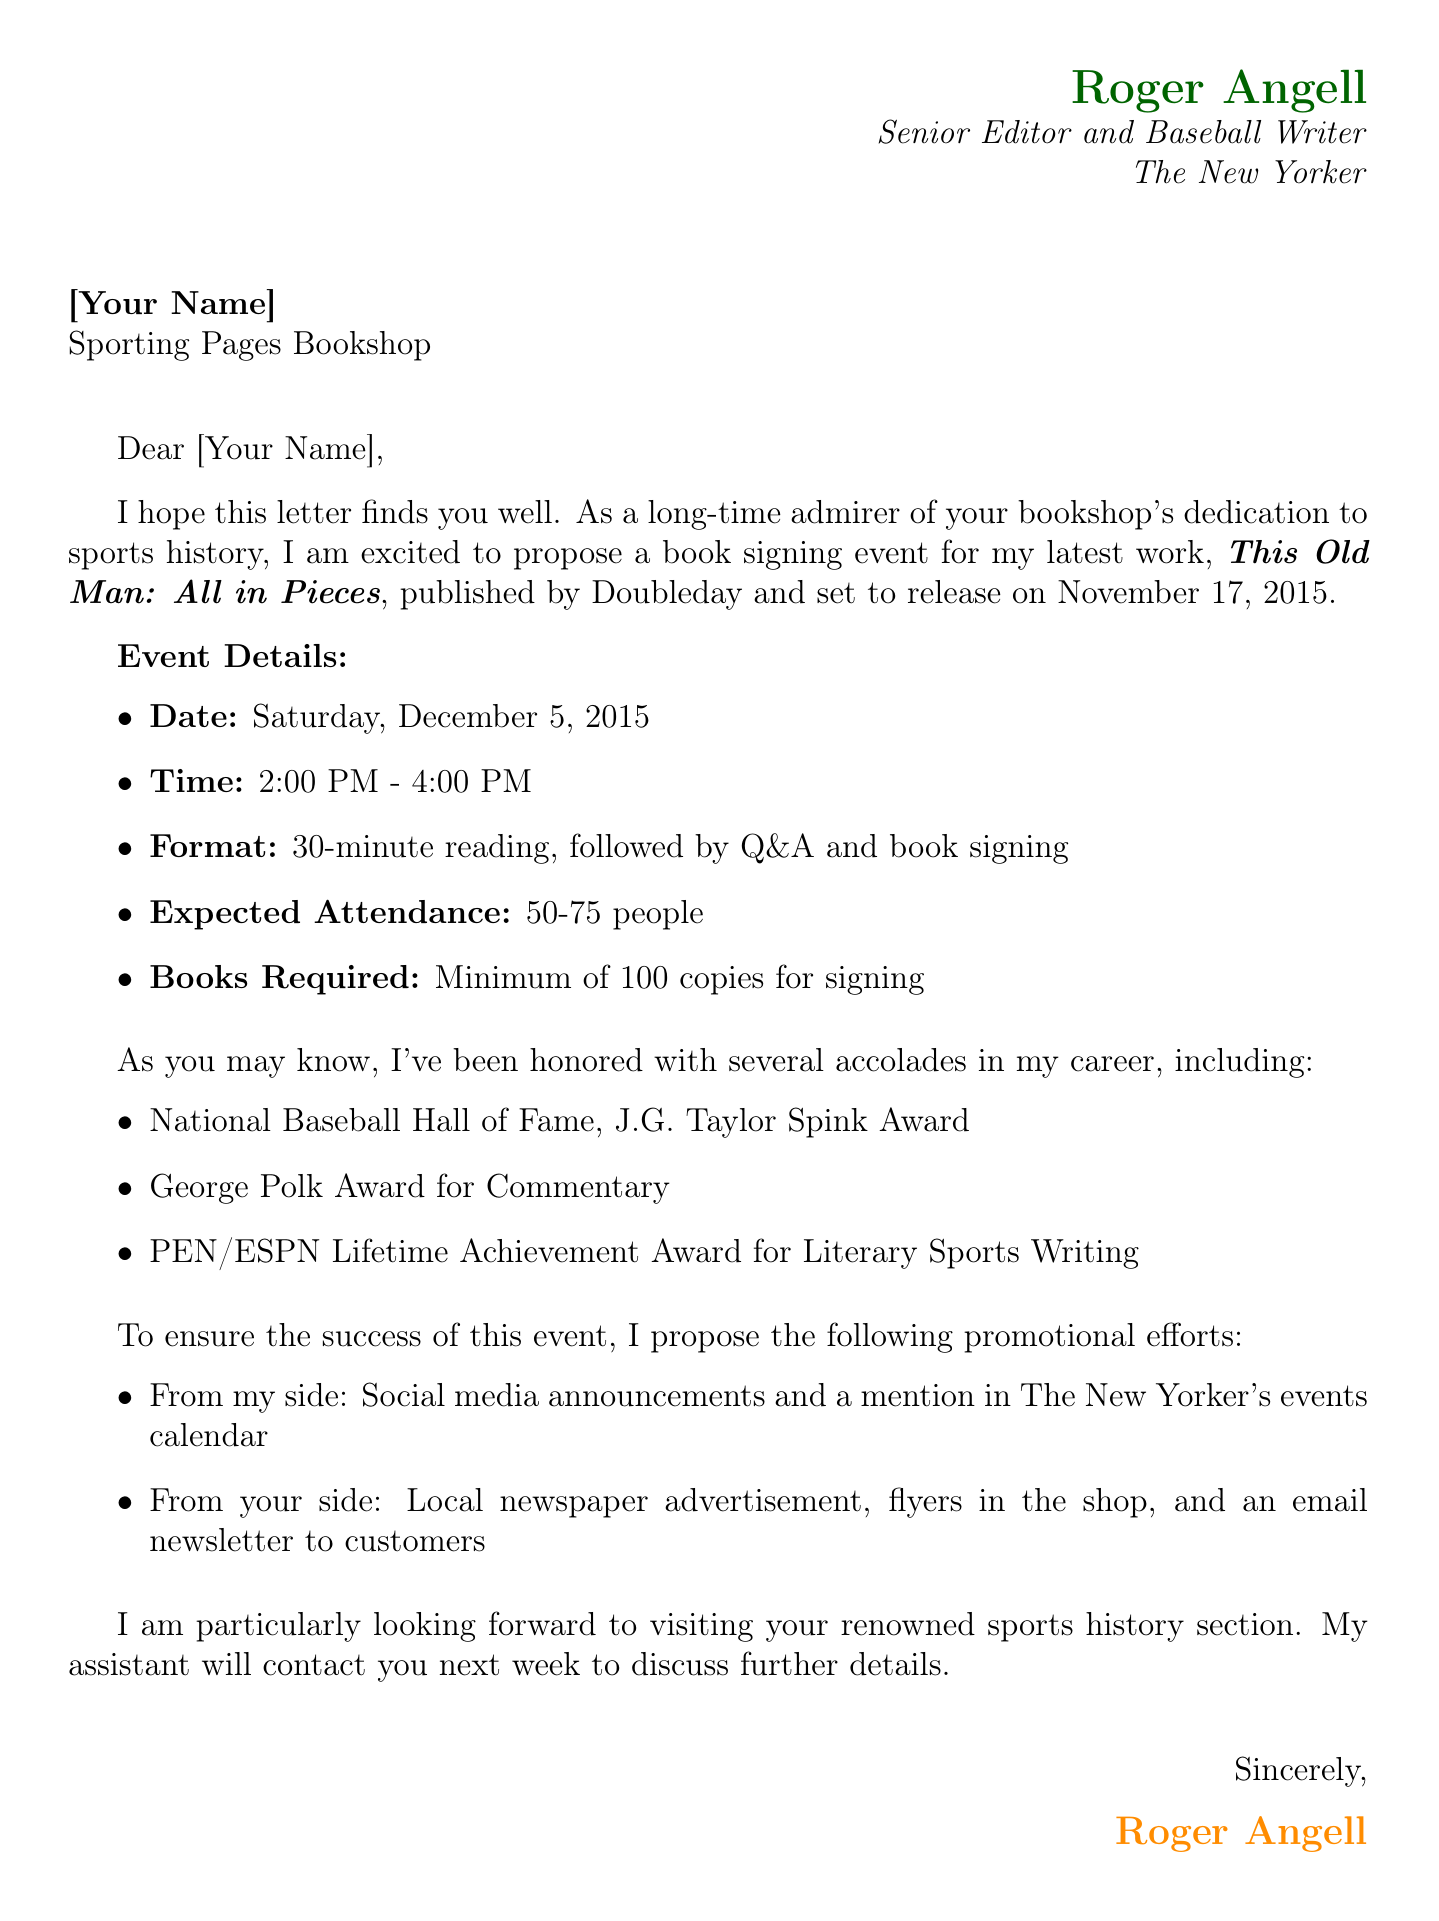What is the name of the author proposing the event? The document states that the author proposing the event is Roger Angell.
Answer: Roger Angell What is the title of the book being promoted? The title of the book mentioned in the document is "This Old Man: All in Pieces."
Answer: This Old Man: All in Pieces What is the suggested date for the book signing event? The document specifies that the suggested date for the event is Saturday, December 5, 2015.
Answer: Saturday, December 5, 2015 What is the expected attendance for the event? The document mentions that the expected attendance is between 50 to 75 people.
Answer: 50-75 people What are the author's accolades listed in the letter? The accolades mentioned in the document include the National Baseball Hall of Fame, George Polk Award, and PEN/ESPN Lifetime Achievement Award.
Answer: National Baseball Hall of Fame, George Polk Award, PEN/ESPN Lifetime Achievement Award What will happen during the event's format? The document outlines that there will be a 30-minute reading, followed by a Q&A and book signing.
Answer: 30-minute reading, followed by Q&A and book signing What promotional support will the author provide for the event? The document states that the author will provide social media announcements and a mention in The New Yorker's events calendar.
Answer: Social media announcements, mention in The New Yorker's events calendar How many copies of the book are required for signing? According to the document, a minimum of 100 copies of the book are required for signing.
Answer: Minimum of 100 copies 